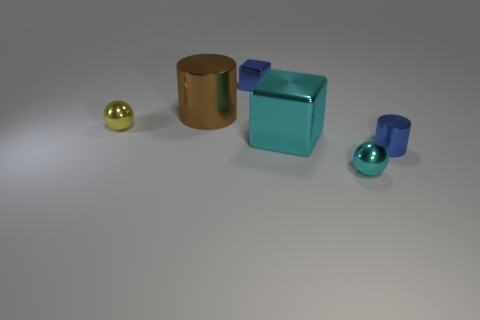Add 2 tiny yellow balls. How many objects exist? 8 Add 2 tiny cyan things. How many tiny cyan things are left? 3 Add 1 brown shiny things. How many brown shiny things exist? 2 Subtract 0 yellow blocks. How many objects are left? 6 Subtract all tiny shiny cylinders. Subtract all large blocks. How many objects are left? 4 